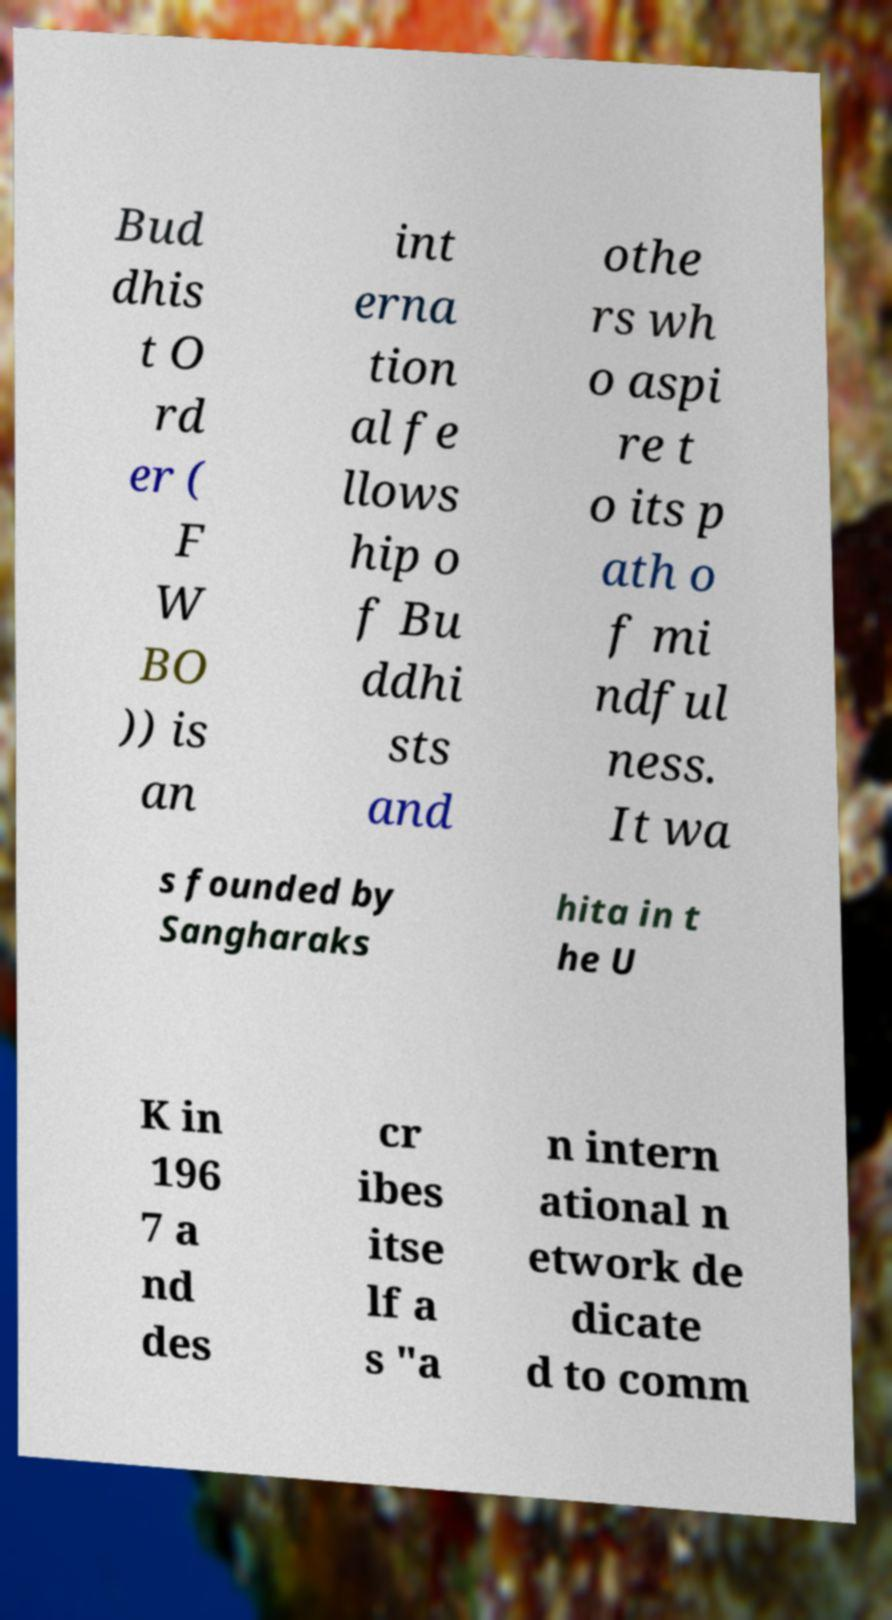For documentation purposes, I need the text within this image transcribed. Could you provide that? Bud dhis t O rd er ( F W BO )) is an int erna tion al fe llows hip o f Bu ddhi sts and othe rs wh o aspi re t o its p ath o f mi ndful ness. It wa s founded by Sangharaks hita in t he U K in 196 7 a nd des cr ibes itse lf a s "a n intern ational n etwork de dicate d to comm 